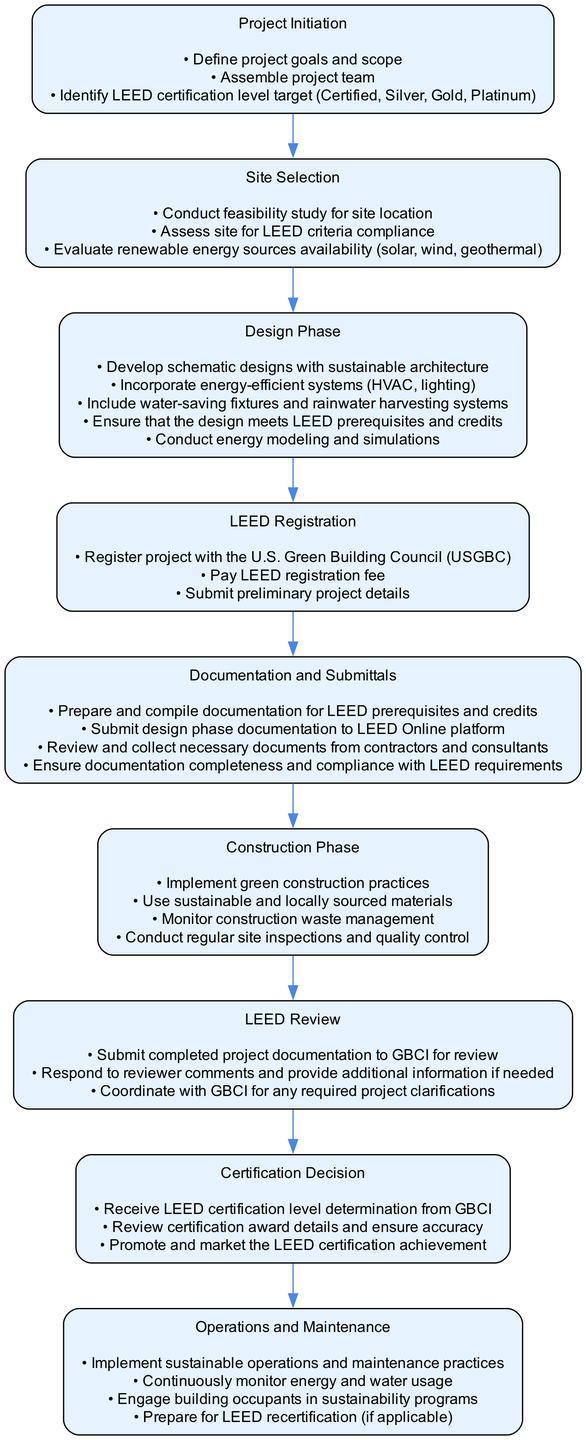What is the first step in the workflow? The first step in the workflow is "Project Initiation". This can be identified as it is the first node in the hierarchy of the flow chart, sequentially leading into the next steps.
Answer: Project Initiation How many nodes are present in the diagram? By counting each step represented in the workflow, we find there are eight distinct steps, each indicated as a node in the diagram.
Answer: Eight Which step comes after the 'Site Selection'? The step that comes after 'Site Selection' in the flow is 'Design Phase'. This can be seen as an orderly connection from the 'Site Selection' node to the 'Design Phase'.
Answer: Design Phase What are the actions listed under 'LEED Review'? The actions listed under 'LEED Review' include: "Submit completed project documentation to GBCI for review", "Respond to reviewer comments and provide additional information if needed", and "Coordinate with GBCI for any required project clarifications". These actions are detailed in the corresponding node representing this workflow step.
Answer: Submit completed project documentation to GBCI for review, Respond to reviewer comments and provide additional information if needed, Coordinate with GBCI for any required project clarifications How does the 'Construction Phase' relate to 'Documentation and Submittals'? The 'Construction Phase' follows the 'Documentation and Submittals', indicating that once all necessary documentation is prepared, the actual construction work begins. This flow illustrates the sequence of activities leading from documentation preparation directly into construction.
Answer: The 'Construction Phase' follows the 'Documentation and Submittals' 